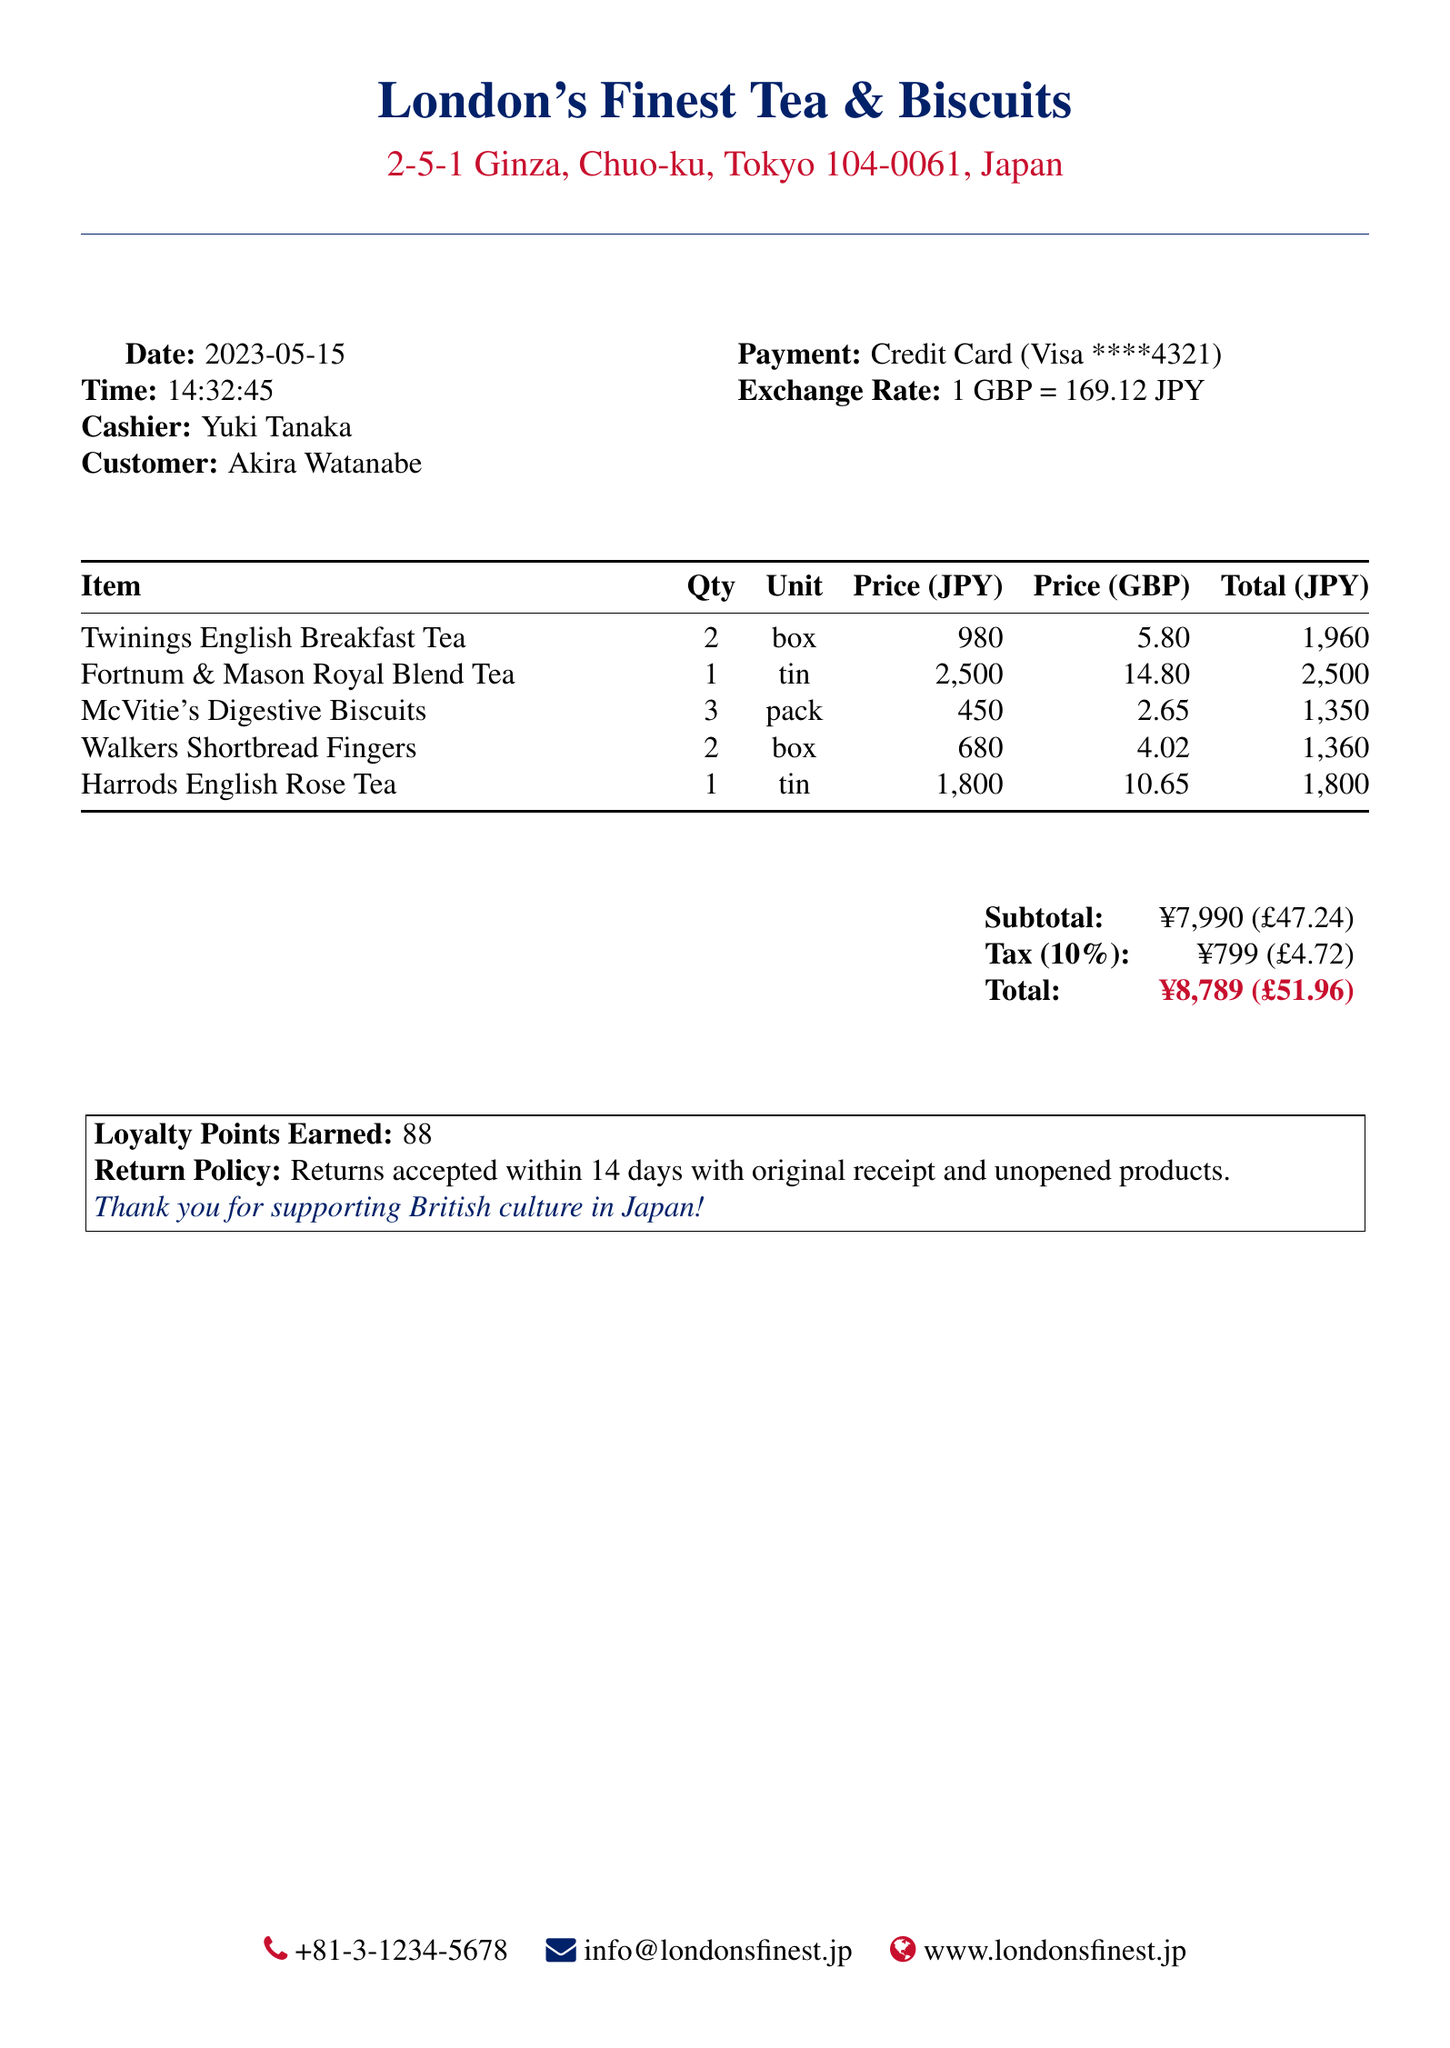What is the store name? The store name is mentioned at the top of the document.
Answer: London's Finest Tea & Biscuits What was the transaction date? The transaction date is explicitly stated under the transaction details.
Answer: 2023-05-15 How many Twinings English Breakfast Tea boxes were purchased? The quantity for each item is listed in the items section of the document.
Answer: 2 What is the total amount paid in yen? The total amount is given at the bottom of the transaction document in the summary section.
Answer: ¥8,789 What loyalty points were earned? The document states the number of loyalty points earned as part of the transaction.
Answer: 88 What is the tax amount in pounds? The tax amount is shown in the summary section alongside other financial details.
Answer: £4.72 Who was the cashier for this transaction? The cashier's name is listed in the transaction details of the document.
Answer: Yuki Tanaka What was the payment method used? The payment method is specified in the customer transaction details.
Answer: Credit Card What is the return policy? The return policy is clearly stated in the document under the loyalty points section.
Answer: Returns accepted within 14 days with original receipt and unopened products 